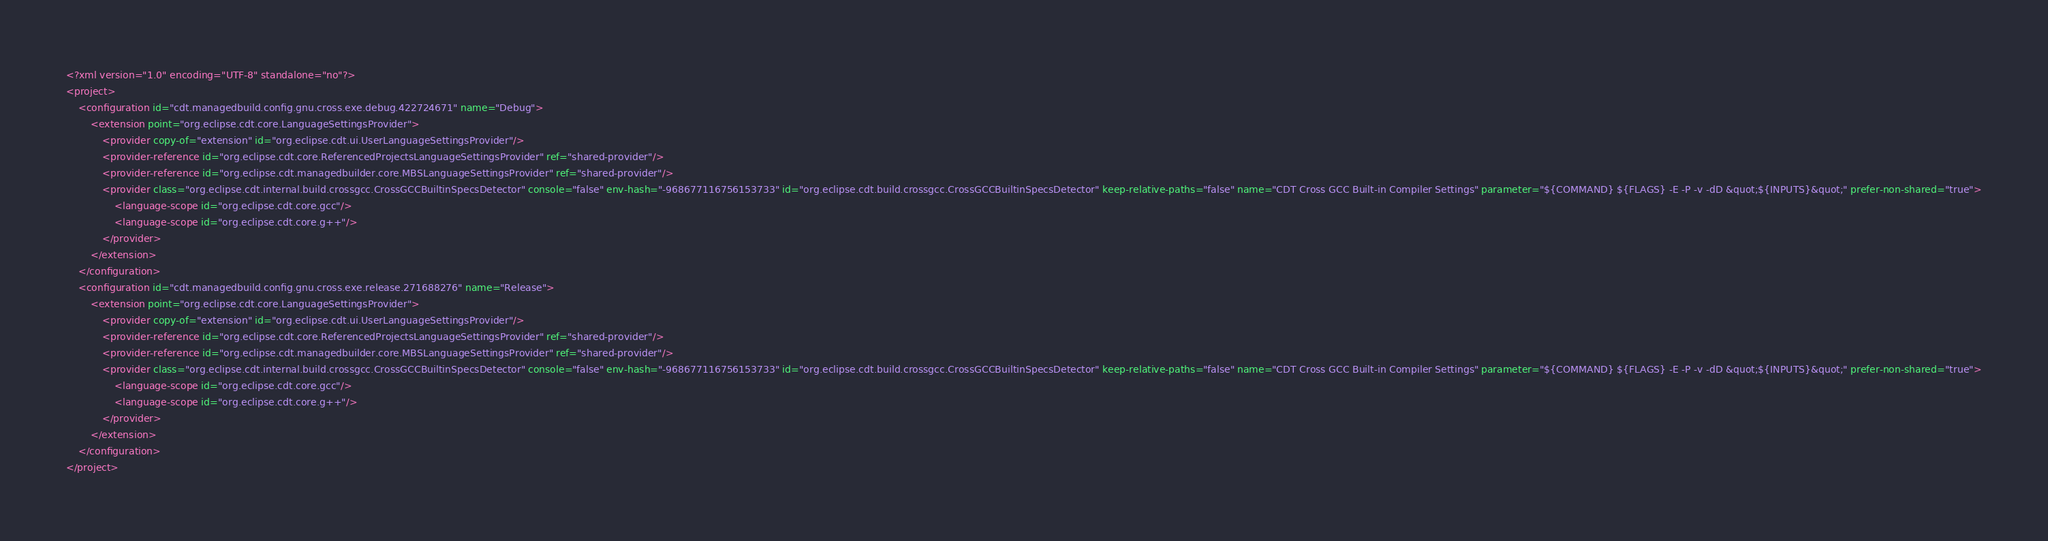Convert code to text. <code><loc_0><loc_0><loc_500><loc_500><_XML_><?xml version="1.0" encoding="UTF-8" standalone="no"?>
<project>
	<configuration id="cdt.managedbuild.config.gnu.cross.exe.debug.422724671" name="Debug">
		<extension point="org.eclipse.cdt.core.LanguageSettingsProvider">
			<provider copy-of="extension" id="org.eclipse.cdt.ui.UserLanguageSettingsProvider"/>
			<provider-reference id="org.eclipse.cdt.core.ReferencedProjectsLanguageSettingsProvider" ref="shared-provider"/>
			<provider-reference id="org.eclipse.cdt.managedbuilder.core.MBSLanguageSettingsProvider" ref="shared-provider"/>
			<provider class="org.eclipse.cdt.internal.build.crossgcc.CrossGCCBuiltinSpecsDetector" console="false" env-hash="-968677116756153733" id="org.eclipse.cdt.build.crossgcc.CrossGCCBuiltinSpecsDetector" keep-relative-paths="false" name="CDT Cross GCC Built-in Compiler Settings" parameter="${COMMAND} ${FLAGS} -E -P -v -dD &quot;${INPUTS}&quot;" prefer-non-shared="true">
				<language-scope id="org.eclipse.cdt.core.gcc"/>
				<language-scope id="org.eclipse.cdt.core.g++"/>
			</provider>
		</extension>
	</configuration>
	<configuration id="cdt.managedbuild.config.gnu.cross.exe.release.271688276" name="Release">
		<extension point="org.eclipse.cdt.core.LanguageSettingsProvider">
			<provider copy-of="extension" id="org.eclipse.cdt.ui.UserLanguageSettingsProvider"/>
			<provider-reference id="org.eclipse.cdt.core.ReferencedProjectsLanguageSettingsProvider" ref="shared-provider"/>
			<provider-reference id="org.eclipse.cdt.managedbuilder.core.MBSLanguageSettingsProvider" ref="shared-provider"/>
			<provider class="org.eclipse.cdt.internal.build.crossgcc.CrossGCCBuiltinSpecsDetector" console="false" env-hash="-968677116756153733" id="org.eclipse.cdt.build.crossgcc.CrossGCCBuiltinSpecsDetector" keep-relative-paths="false" name="CDT Cross GCC Built-in Compiler Settings" parameter="${COMMAND} ${FLAGS} -E -P -v -dD &quot;${INPUTS}&quot;" prefer-non-shared="true">
				<language-scope id="org.eclipse.cdt.core.gcc"/>
				<language-scope id="org.eclipse.cdt.core.g++"/>
			</provider>
		</extension>
	</configuration>
</project>
</code> 